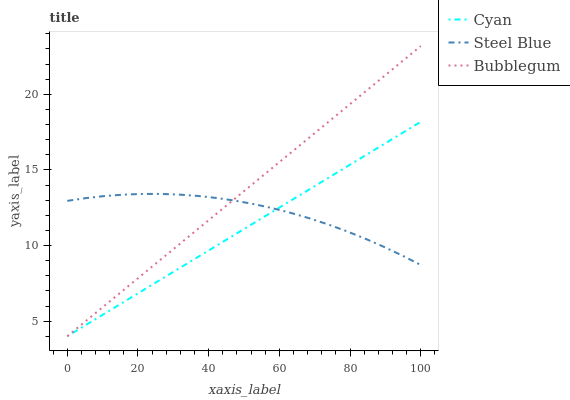Does Cyan have the minimum area under the curve?
Answer yes or no. Yes. Does Bubblegum have the maximum area under the curve?
Answer yes or no. Yes. Does Steel Blue have the minimum area under the curve?
Answer yes or no. No. Does Steel Blue have the maximum area under the curve?
Answer yes or no. No. Is Cyan the smoothest?
Answer yes or no. Yes. Is Steel Blue the roughest?
Answer yes or no. Yes. Is Bubblegum the smoothest?
Answer yes or no. No. Is Bubblegum the roughest?
Answer yes or no. No. Does Cyan have the lowest value?
Answer yes or no. Yes. Does Steel Blue have the lowest value?
Answer yes or no. No. Does Bubblegum have the highest value?
Answer yes or no. Yes. Does Steel Blue have the highest value?
Answer yes or no. No. Does Steel Blue intersect Cyan?
Answer yes or no. Yes. Is Steel Blue less than Cyan?
Answer yes or no. No. Is Steel Blue greater than Cyan?
Answer yes or no. No. 